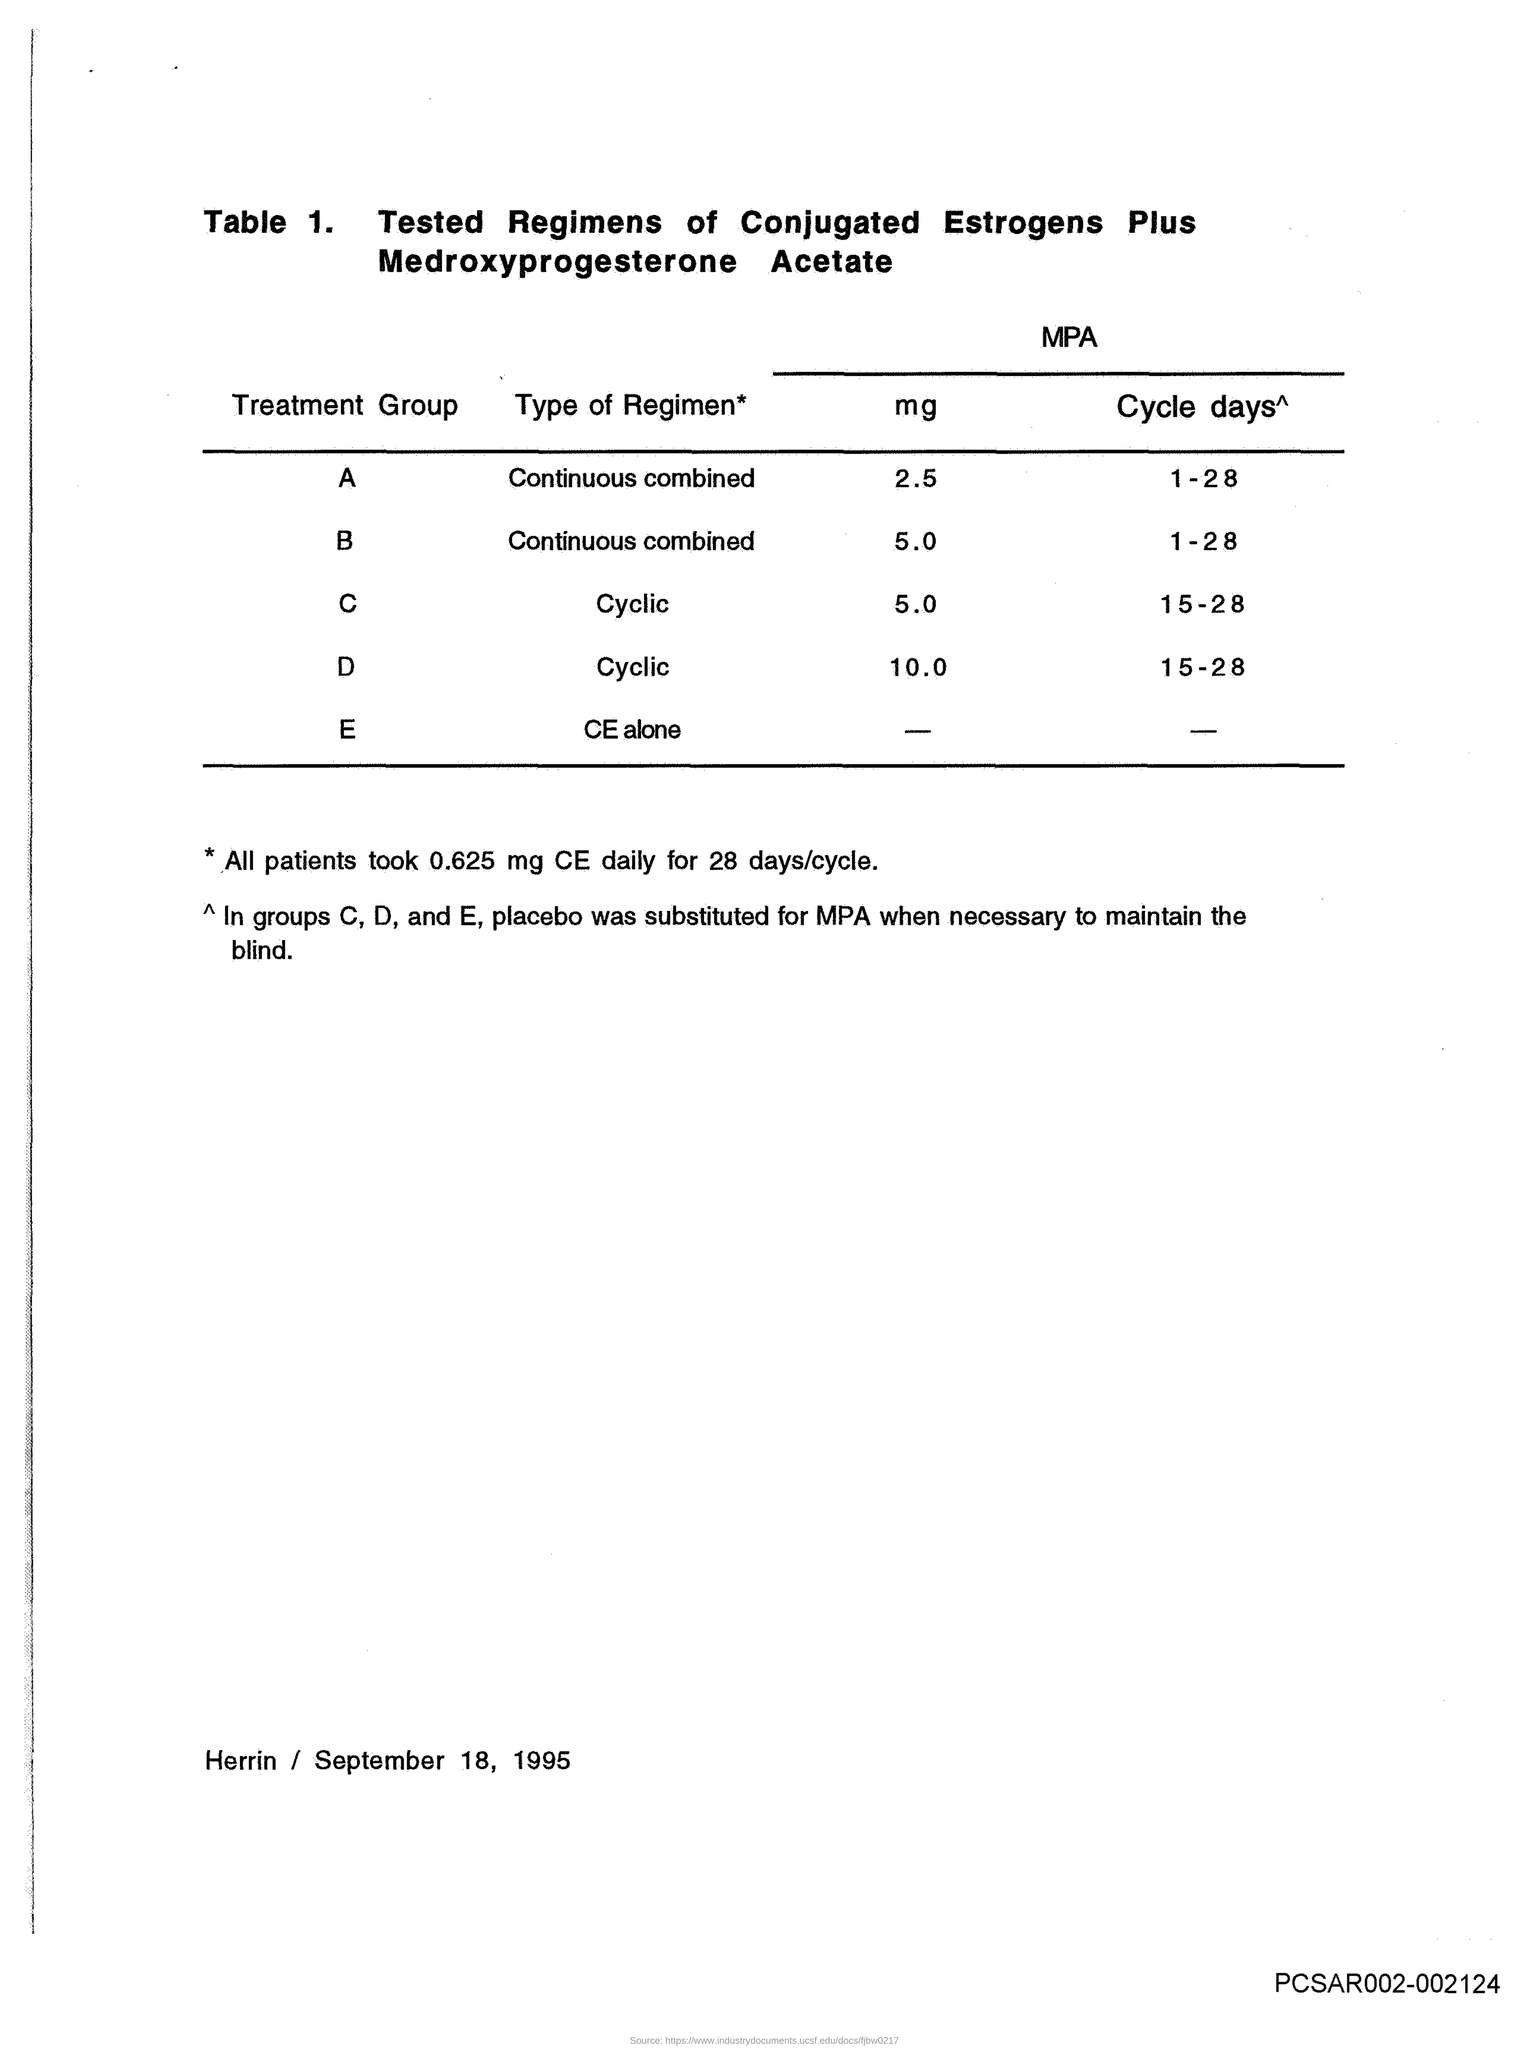Highlight a few significant elements in this photo. The MPA-Cycle days required for treatment group C are 15 to 28. The MPA-mg for the treatment group A is 2.5. The MPA-Cycle days for treatment group D is 15-28. The MPA-Cycle treatment group A is scheduled for 1-28 days of treatment. The MPA-mg for treatment group C is 5.0. 